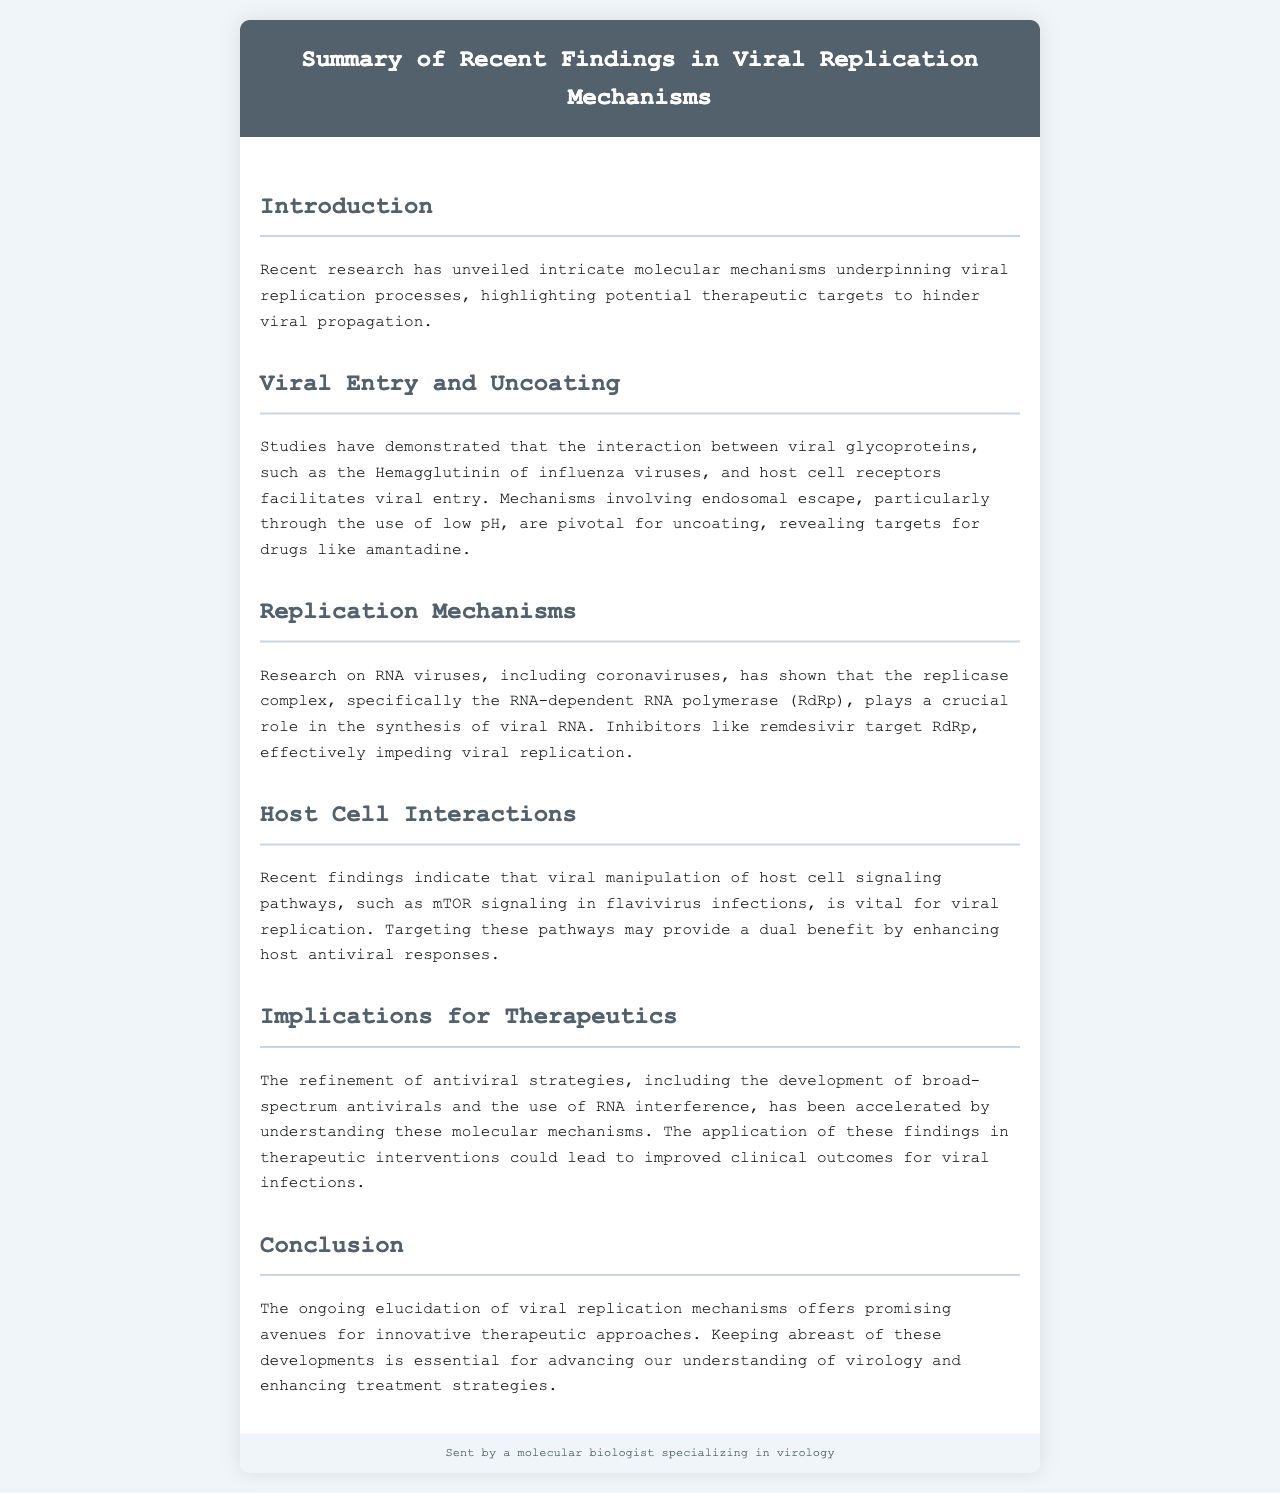What is the main focus of the recent research? The main focus of the recent research is on the intricate molecular mechanisms underpinning viral replication processes.
Answer: Viral replication mechanisms Which viral glycoprotein is mentioned in relation to viral entry? The document mentions Hemagglutinin of influenza viruses in relation to viral entry.
Answer: Hemagglutinin What is the role of the RNA-dependent RNA polymerase? The RNA-dependent RNA polymerase (RdRp) is crucial for the synthesis of viral RNA.
Answer: Synthesis of viral RNA Which antiviral drug is mentioned as a target for RdRp? The document states that remdesivir targets RdRp to impede viral replication.
Answer: Remdesivir What signaling pathway is highlighted in flavivirus infections? The mTOR signaling pathway is highlighted as being vital for viral replication in flavivirus infections.
Answer: mTOR signaling How does the document describe the potential benefit of targeting host cell pathways? It suggests that targeting these pathways may enhance host antiviral responses, providing a dual benefit.
Answer: Enhance host antiviral responses What is the conclusion regarding viral replication mechanisms? The conclusion emphasizes that ongoing elucidation of viral replication mechanisms offers promising avenues for therapeutic approaches.
Answer: Promising avenues for therapeutic approaches What type of antiviral strategies are mentioned as a focus of refinement? The document mentions the development of broad-spectrum antivirals as a focus of refinement.
Answer: Broad-spectrum antivirals 